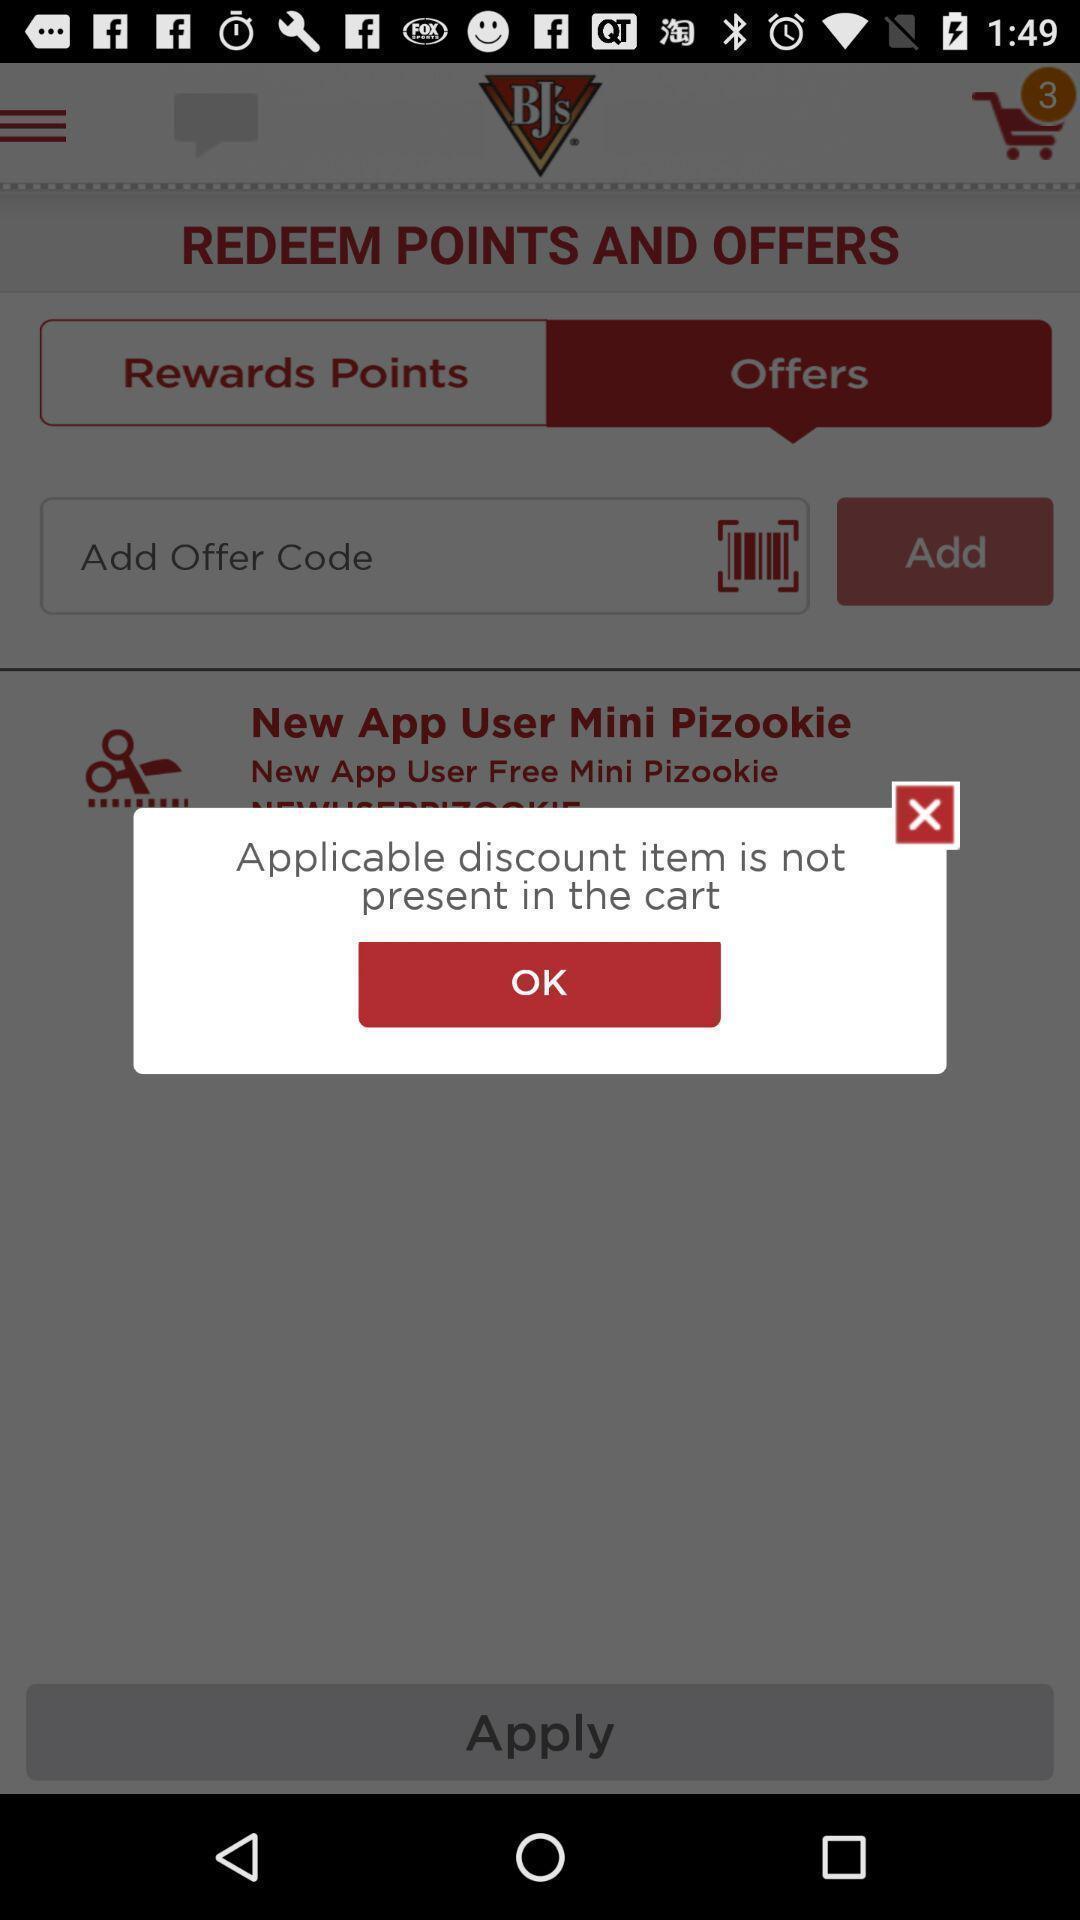Provide a textual representation of this image. Popup displaying no offers available. 